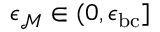<formula> <loc_0><loc_0><loc_500><loc_500>\epsilon _ { \mathcal { M } } \in ( 0 , \epsilon _ { b c } ]</formula> 